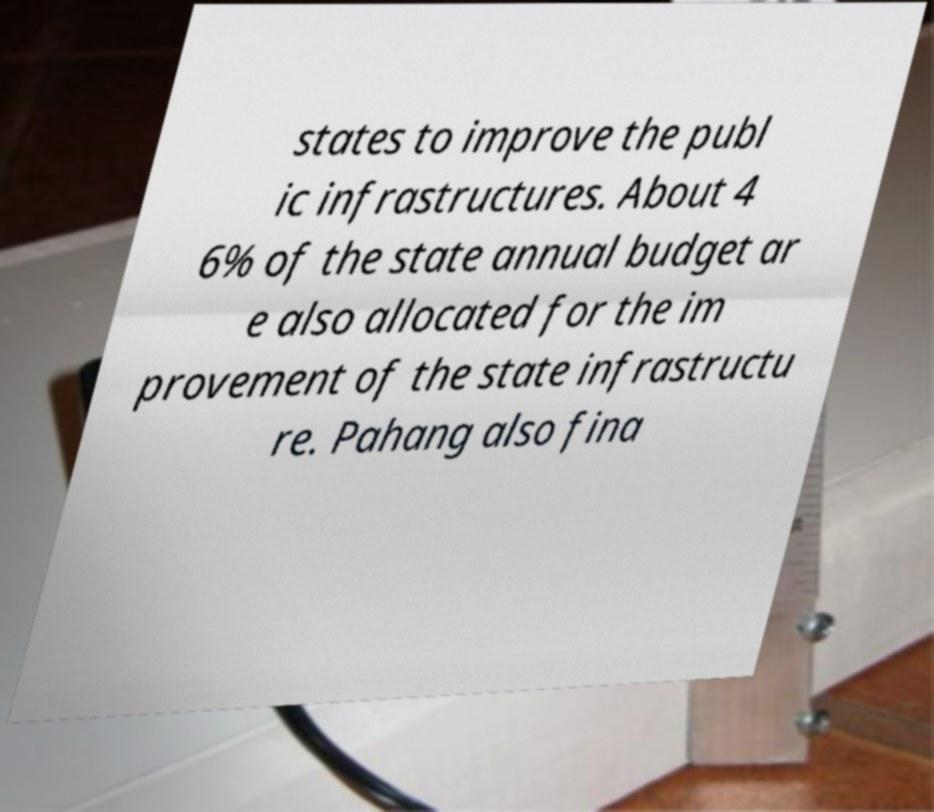There's text embedded in this image that I need extracted. Can you transcribe it verbatim? states to improve the publ ic infrastructures. About 4 6% of the state annual budget ar e also allocated for the im provement of the state infrastructu re. Pahang also fina 